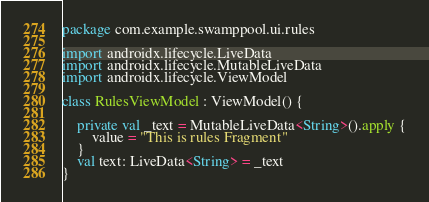Convert code to text. <code><loc_0><loc_0><loc_500><loc_500><_Kotlin_>package com.example.swamppool.ui.rules

import androidx.lifecycle.LiveData
import androidx.lifecycle.MutableLiveData
import androidx.lifecycle.ViewModel

class RulesViewModel : ViewModel() {

    private val _text = MutableLiveData<String>().apply {
        value = "This is rules Fragment"
    }
    val text: LiveData<String> = _text
}
</code> 